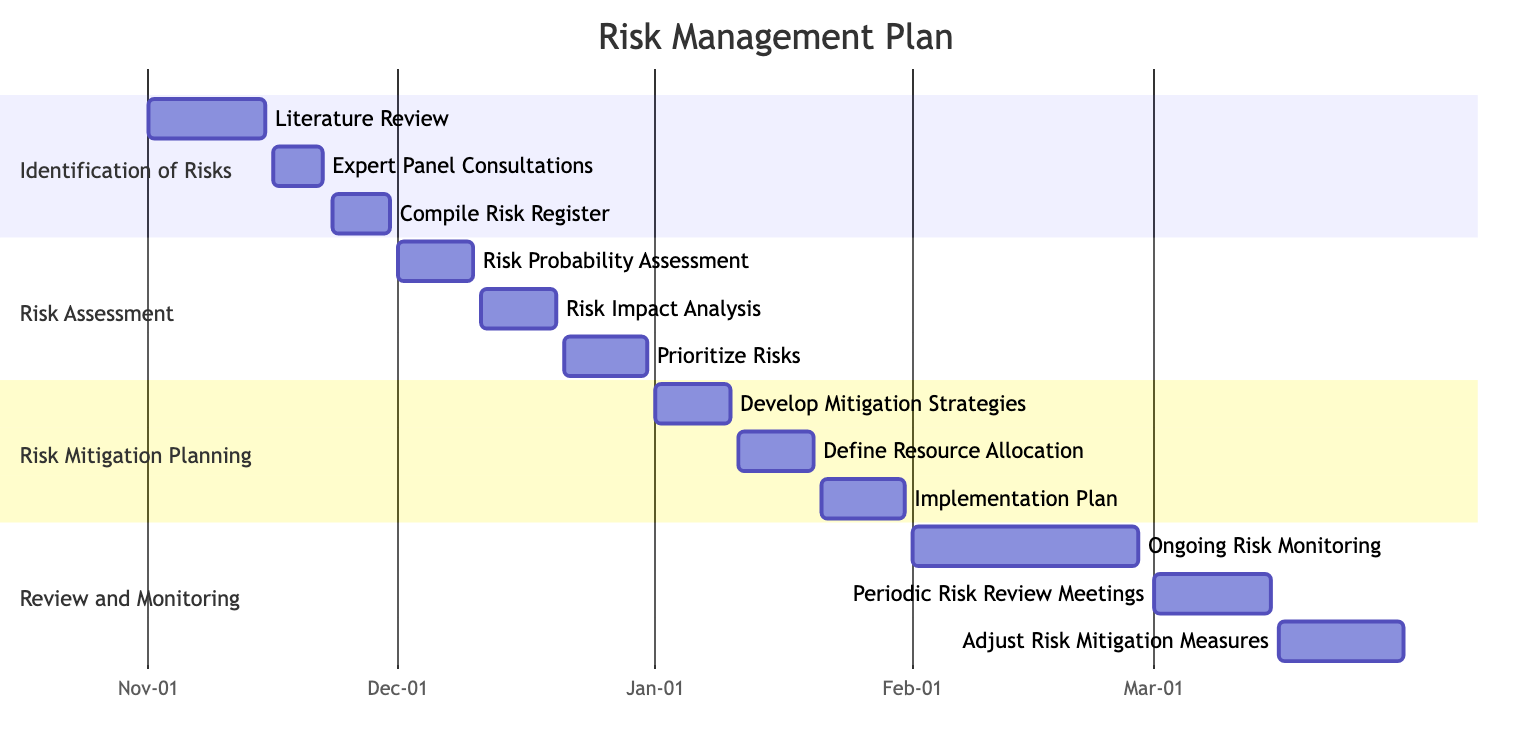What is the start date for the "Ongoing Risk Monitoring" task? The "Ongoing Risk Monitoring" task is listed in the "Review and Monitoring" section, and its start date is directly provided in the diagram as "2024-02-01".
Answer: 2024-02-01 How many subtasks are there in the "Risk Assessment" section? The "Risk Assessment" section contains three subtasks: "Risk Probability Assessment," "Risk Impact Analysis," and "Prioritize Risks." Thus, the total number of subtasks is three.
Answer: 3 What is the end date for the "Compile Risk Register" task? The end date for "Compile Risk Register" is specified in the "Identification of Risks" section as "2023-11-30."
Answer: 2023-11-30 Which task follows "Risk Impact Analysis" in the timeline? "Risk Impact Analysis" ends on "2023-12-20," and the next task listed is "Prioritize Risks," which starts on "2023-12-21." Therefore, "Prioritize Risks" follows "Risk Impact Analysis."
Answer: Prioritize Risks What is the duration of the "Define Resource Allocation" subtask? "Define Resource Allocation" starts on "2024-01-11" and ends on "2024-01-20." Counting from the start to the end date (10 days total), the duration is 10 days.
Answer: 10 days How many tasks are in the "Risk Mitigation Planning" section? In the "Risk Mitigation Planning" section, there are three tasks: "Develop Mitigation Strategies," "Define Resource Allocation," and "Implementation Plan." Hence, the number of tasks is three.
Answer: 3 Which subtask has the earliest start date in the entire plan? The earliest start date is for "Literature Review," which begins on "2023-11-01." This task is part of the "Identification of Risks" section.
Answer: Literature Review What is the last task listed in the Gantt chart? The last task noted in the Gantt chart is "Adjust Risk Mitigation Measures," which is part of the "Review and Monitoring" section and ends on "2024-03-31."
Answer: Adjust Risk Mitigation Measures 